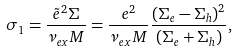<formula> <loc_0><loc_0><loc_500><loc_500>\sigma _ { 1 } = \frac { { \tilde { e } } ^ { 2 } \Sigma } { \nu _ { e x } M } = \frac { e ^ { 2 } } { \nu _ { e x } M } \frac { ( \Sigma _ { e } - \Sigma _ { h } ) ^ { 2 } } { ( \Sigma _ { e } + \Sigma _ { h } ) } ,</formula> 